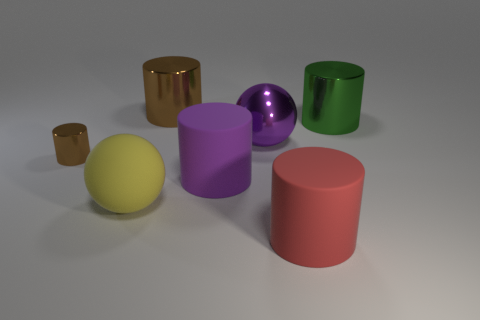Are there more tiny brown shiny objects in front of the rubber ball than green cylinders?
Give a very brief answer. No. There is a metal ball; how many green things are left of it?
Keep it short and to the point. 0. Is there another green object of the same size as the green object?
Make the answer very short. No. The other big metallic object that is the same shape as the big green object is what color?
Give a very brief answer. Brown. Do the red cylinder right of the purple shiny object and the brown shiny cylinder that is in front of the purple metal thing have the same size?
Your answer should be very brief. No. Are there any yellow matte things of the same shape as the large red rubber thing?
Provide a short and direct response. No. Are there an equal number of green metal objects in front of the red rubber cylinder and large cyan metallic things?
Offer a very short reply. Yes. Is the size of the yellow thing the same as the metallic cylinder to the left of the large brown object?
Your answer should be compact. No. How many green objects have the same material as the big brown object?
Give a very brief answer. 1. Is there any other thing that is the same color as the rubber ball?
Keep it short and to the point. No. 